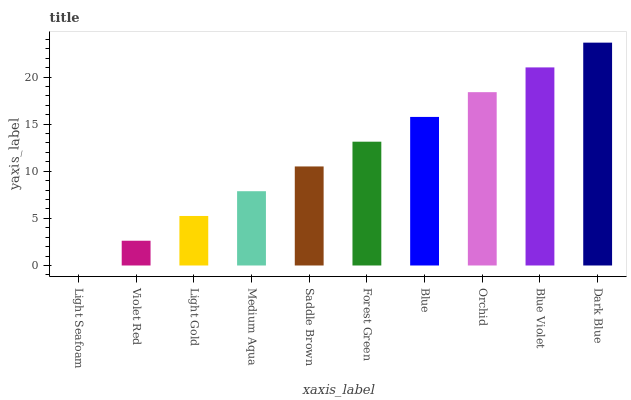Is Light Seafoam the minimum?
Answer yes or no. Yes. Is Dark Blue the maximum?
Answer yes or no. Yes. Is Violet Red the minimum?
Answer yes or no. No. Is Violet Red the maximum?
Answer yes or no. No. Is Violet Red greater than Light Seafoam?
Answer yes or no. Yes. Is Light Seafoam less than Violet Red?
Answer yes or no. Yes. Is Light Seafoam greater than Violet Red?
Answer yes or no. No. Is Violet Red less than Light Seafoam?
Answer yes or no. No. Is Forest Green the high median?
Answer yes or no. Yes. Is Saddle Brown the low median?
Answer yes or no. Yes. Is Saddle Brown the high median?
Answer yes or no. No. Is Medium Aqua the low median?
Answer yes or no. No. 